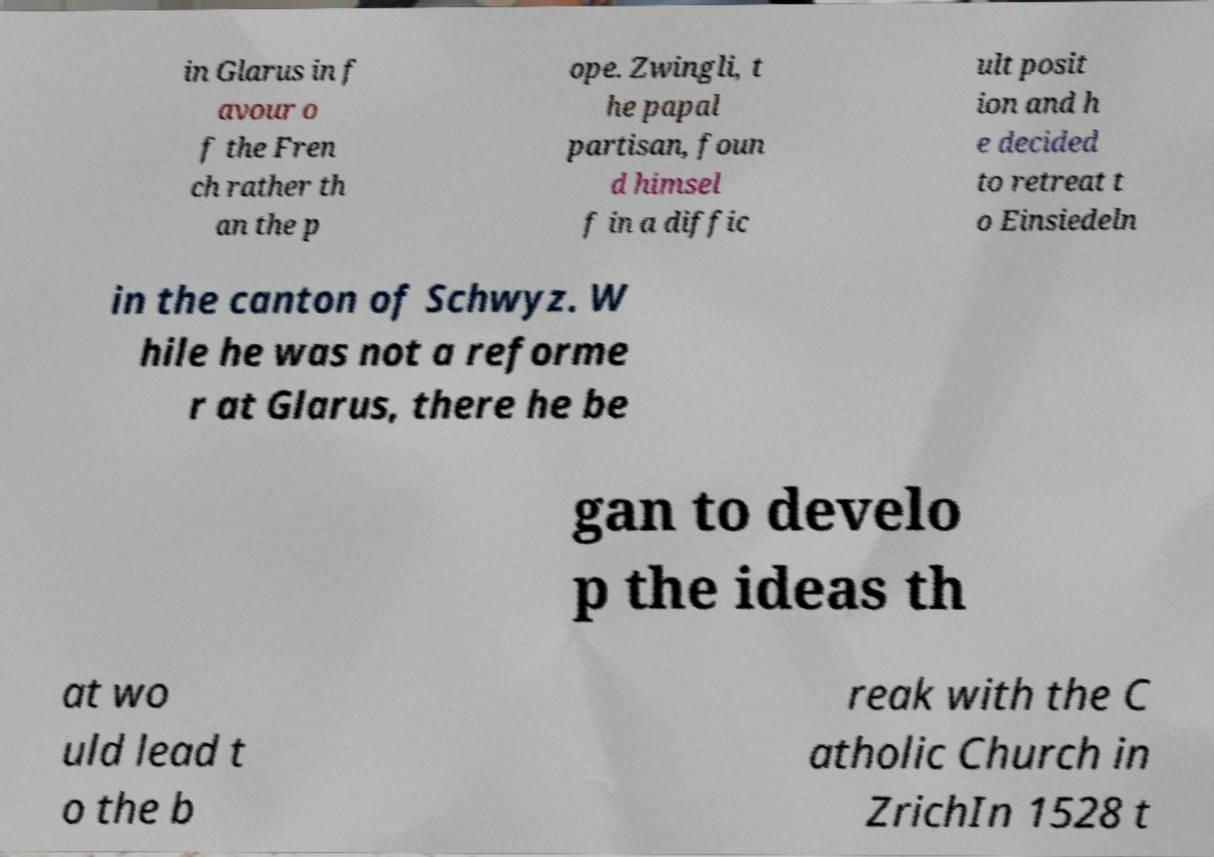For documentation purposes, I need the text within this image transcribed. Could you provide that? in Glarus in f avour o f the Fren ch rather th an the p ope. Zwingli, t he papal partisan, foun d himsel f in a diffic ult posit ion and h e decided to retreat t o Einsiedeln in the canton of Schwyz. W hile he was not a reforme r at Glarus, there he be gan to develo p the ideas th at wo uld lead t o the b reak with the C atholic Church in ZrichIn 1528 t 